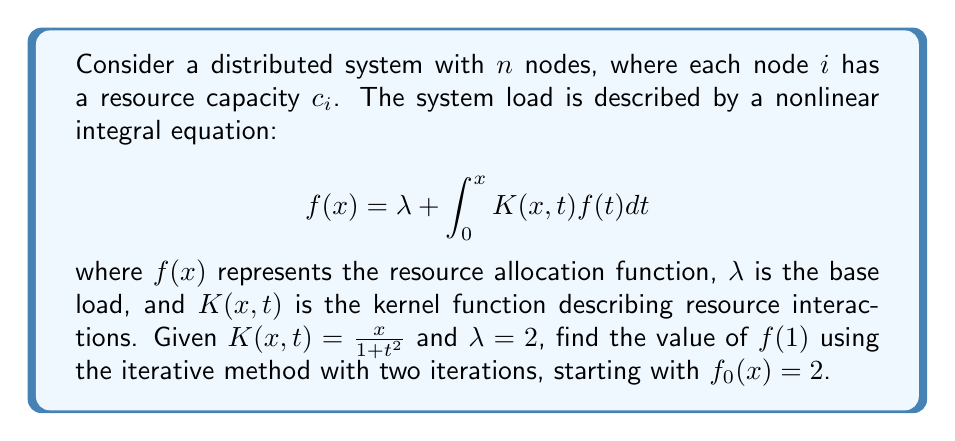Teach me how to tackle this problem. To solve this nonlinear integral equation, we'll use the iterative method:

1. Start with $f_0(x) = 2$

2. For the first iteration:
   $$f_1(x) = \lambda + \int_0^x K(x,t)f_0(t)dt$$
   $$f_1(x) = 2 + \int_0^x \frac{x}{1+t^2} \cdot 2 dt$$
   $$f_1(x) = 2 + 2x \int_0^x \frac{1}{1+t^2} dt$$
   $$f_1(x) = 2 + 2x \cdot \arctan(x)$$

3. For the second iteration:
   $$f_2(x) = 2 + \int_0^x \frac{x}{1+t^2} \cdot (2 + 2t \cdot \arctan(t)) dt$$
   $$f_2(x) = 2 + 2x \cdot \arctan(x) + 2x \int_0^x \frac{t \cdot \arctan(t)}{1+t^2} dt$$

4. To evaluate the last integral, we can use numerical integration or approximation methods. Using Simpson's rule with 4 subintervals:
   $$\int_0^1 \frac{t \cdot \arctan(t)}{1+t^2} dt \approx \frac{1}{12} (0 + 4 \cdot 0.0624 + 2 \cdot 0.1974 + 4 \cdot 0.2493 + 0.2450) \approx 0.1584$$

5. Substituting $x=1$ in the expression for $f_2(x)$:
   $$f_2(1) = 2 + 2 \cdot \arctan(1) + 2 \cdot 0.1584$$
   $$f_2(1) = 2 + 2 \cdot \frac{\pi}{4} + 0.3168$$
   $$f_2(1) \approx 3.8853$$
Answer: $f(1) \approx 3.8853$ 